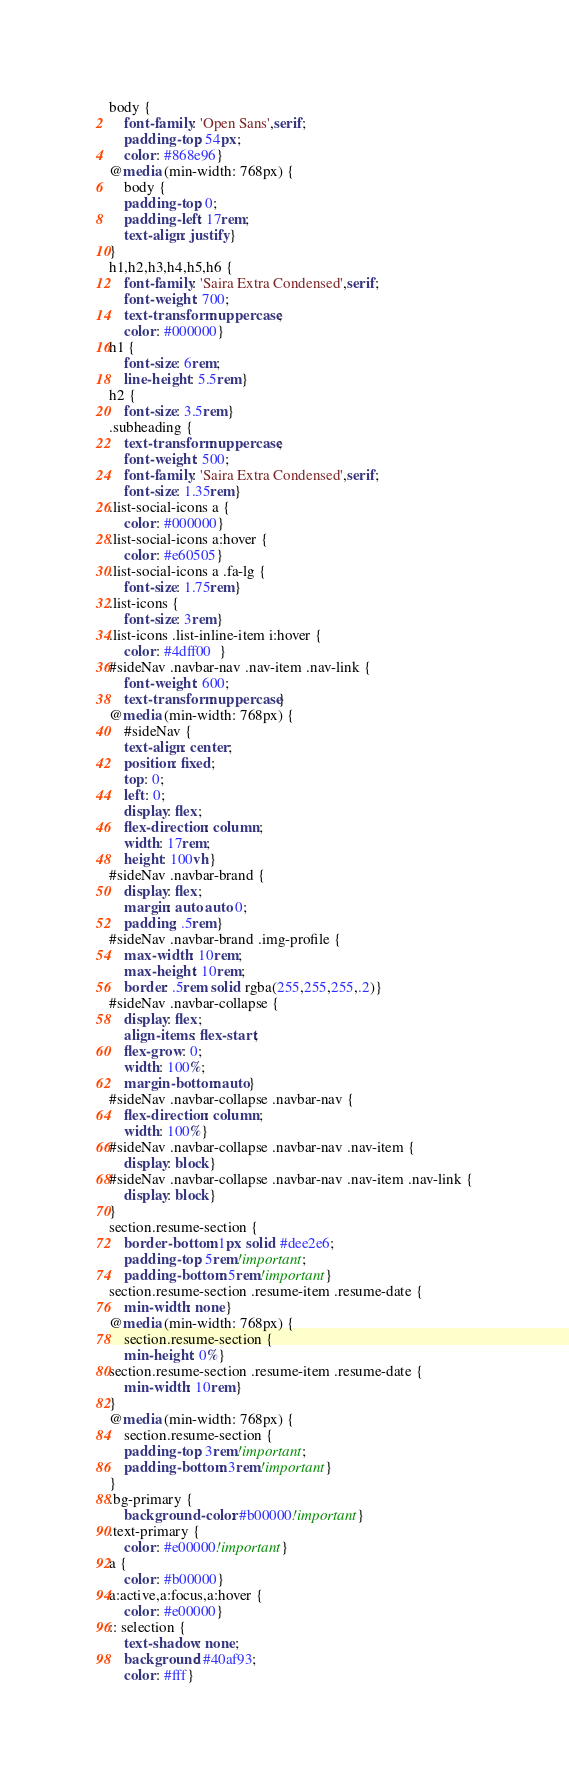Convert code to text. <code><loc_0><loc_0><loc_500><loc_500><_CSS_>body {
    font-family: 'Open Sans',serif;
    padding-top: 54px;
    color: #868e96}
@media (min-width: 768px) {
    body {
    padding-top: 0;
    padding-left: 17rem;
    text-align: justify}
}
h1,h2,h3,h4,h5,h6 {
    font-family: 'Saira Extra Condensed',serif;
    font-weight: 700;
    text-transform: uppercase;
    color: #000000}
h1 {
    font-size: 6rem;
    line-height: 5.5rem}
h2 {
    font-size: 3.5rem}
.subheading {
    text-transform: uppercase;
    font-weight: 500;
    font-family: 'Saira Extra Condensed',serif;
    font-size: 1.35rem}
.list-social-icons a {
    color: #000000}
.list-social-icons a:hover {
    color: #e60505}
.list-social-icons a .fa-lg {
    font-size: 1.75rem}
.list-icons {
    font-size: 3rem}
.list-icons .list-inline-item i:hover {
    color: #4dff00  }
#sideNav .navbar-nav .nav-item .nav-link {
    font-weight: 600;
    text-transform: uppercase}
@media (min-width: 768px) {
    #sideNav {
    text-align: center;
    position: fixed;
    top: 0;
    left: 0;
    display: flex;
    flex-direction: column;
    width: 17rem;
    height: 100vh}
#sideNav .navbar-brand {
    display: flex;
    margin: auto auto 0;
    padding: .5rem}
#sideNav .navbar-brand .img-profile {
    max-width: 10rem;
    max-height: 10rem;
    border: .5rem solid rgba(255,255,255,.2)}
#sideNav .navbar-collapse {
    display: flex;
    align-items: flex-start;
    flex-grow: 0;
    width: 100%;
    margin-bottom: auto}
#sideNav .navbar-collapse .navbar-nav {
    flex-direction: column;
    width: 100%}
#sideNav .navbar-collapse .navbar-nav .nav-item {
    display: block}
#sideNav .navbar-collapse .navbar-nav .nav-item .nav-link {
    display: block}
}
section.resume-section {
    border-bottom: 1px solid #dee2e6;
    padding-top: 5rem!important;
    padding-bottom: 5rem!important}
section.resume-section .resume-item .resume-date {
    min-width: none}
@media (min-width: 768px) {
    section.resume-section {
    min-height: 0%}
section.resume-section .resume-item .resume-date {
    min-width: 10rem}
}
@media (min-width: 768px) {
    section.resume-section {
    padding-top: 3rem!important;
    padding-bottom: 3rem!important}
}
.bg-primary {
    background-color: #b00000!important}
.text-primary {
    color: #e00000!important}
a {
    color: #b00000}
a:active,a:focus,a:hover {
    color: #e00000}
:: selection {
    text-shadow: none;
    background: #40af93;
    color: #fff}
</code> 